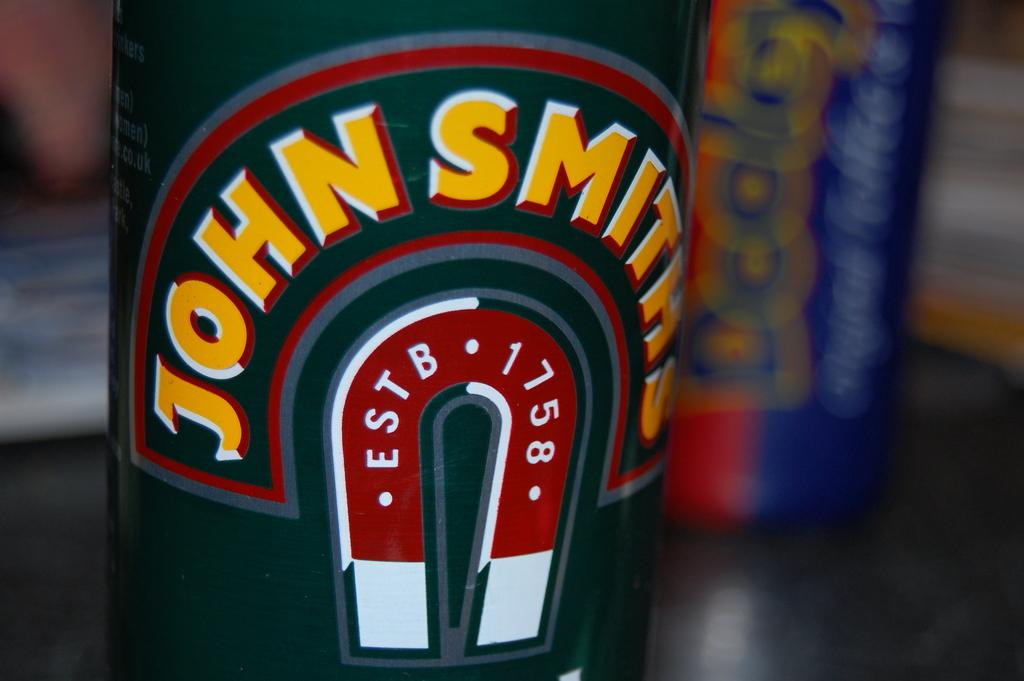Provide a one-sentence caption for the provided image. Close up of John Smith which was estb in 1758. 